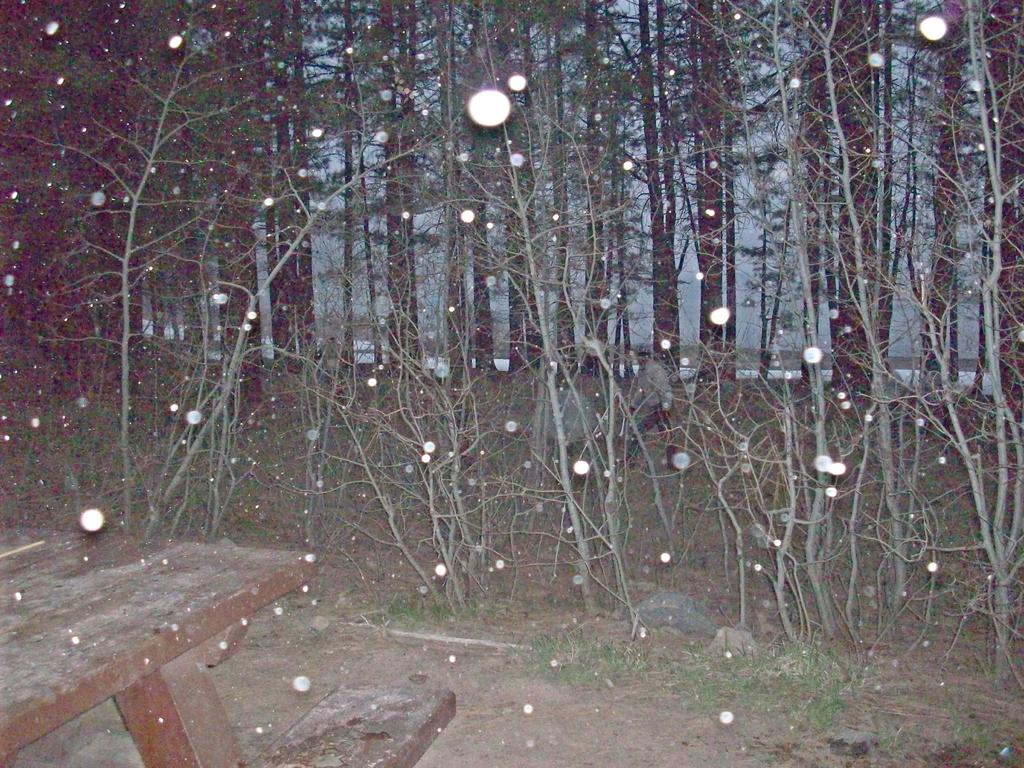What type of seating is visible in the image? There is a bench in the image. What type of vegetation is present in the image? There is grass in the image. What type of natural elements can be seen in the image? There are stones and trees in the image. What else can be seen in the image besides the bench, grass, stones, and trees? There are objects and people in the image. What type of rhythm is being played by the trees in the image? There is no rhythm being played by the trees in the image, as trees do not produce music or rhythm. What type of behavior is being exhibited by the stones in the image? There is no behavior being exhibited by the stones in the image, as stones are inanimate objects and do not exhibit behavior. 